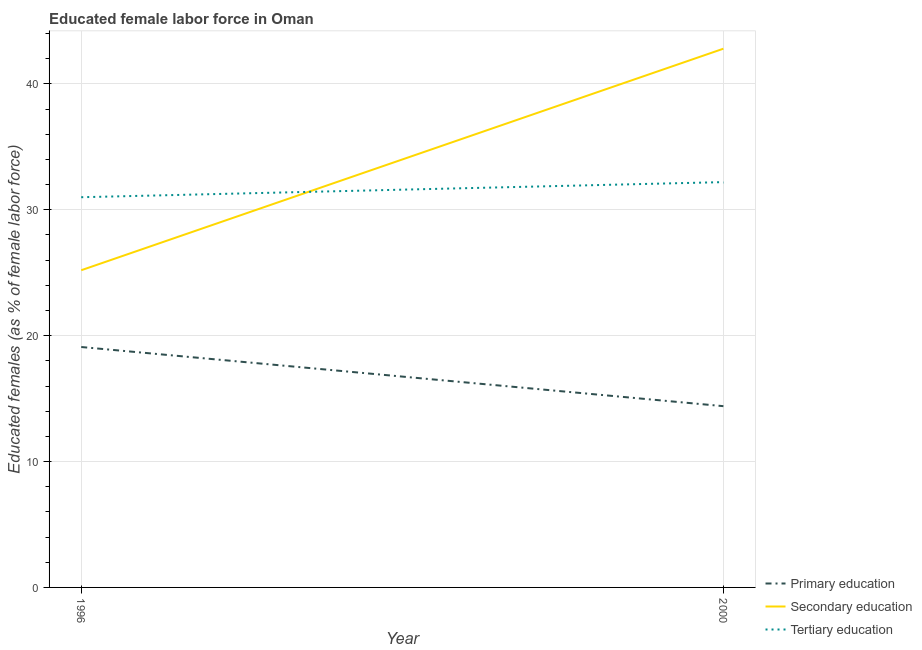What is the percentage of female labor force who received primary education in 1996?
Keep it short and to the point. 19.1. Across all years, what is the maximum percentage of female labor force who received primary education?
Keep it short and to the point. 19.1. Across all years, what is the minimum percentage of female labor force who received secondary education?
Give a very brief answer. 25.2. What is the total percentage of female labor force who received tertiary education in the graph?
Make the answer very short. 63.2. What is the difference between the percentage of female labor force who received primary education in 1996 and that in 2000?
Give a very brief answer. 4.7. What is the difference between the percentage of female labor force who received primary education in 1996 and the percentage of female labor force who received tertiary education in 2000?
Your answer should be compact. -13.1. What is the average percentage of female labor force who received tertiary education per year?
Offer a very short reply. 31.6. In the year 1996, what is the difference between the percentage of female labor force who received secondary education and percentage of female labor force who received tertiary education?
Provide a succinct answer. -5.8. What is the ratio of the percentage of female labor force who received tertiary education in 1996 to that in 2000?
Your answer should be very brief. 0.96. Is the percentage of female labor force who received secondary education in 1996 less than that in 2000?
Your answer should be very brief. Yes. What is the difference between two consecutive major ticks on the Y-axis?
Make the answer very short. 10. Are the values on the major ticks of Y-axis written in scientific E-notation?
Provide a short and direct response. No. Does the graph contain any zero values?
Make the answer very short. No. How many legend labels are there?
Offer a very short reply. 3. How are the legend labels stacked?
Offer a very short reply. Vertical. What is the title of the graph?
Ensure brevity in your answer.  Educated female labor force in Oman. What is the label or title of the X-axis?
Make the answer very short. Year. What is the label or title of the Y-axis?
Provide a short and direct response. Educated females (as % of female labor force). What is the Educated females (as % of female labor force) in Primary education in 1996?
Ensure brevity in your answer.  19.1. What is the Educated females (as % of female labor force) in Secondary education in 1996?
Keep it short and to the point. 25.2. What is the Educated females (as % of female labor force) of Tertiary education in 1996?
Provide a succinct answer. 31. What is the Educated females (as % of female labor force) of Primary education in 2000?
Ensure brevity in your answer.  14.4. What is the Educated females (as % of female labor force) of Secondary education in 2000?
Make the answer very short. 42.8. What is the Educated females (as % of female labor force) of Tertiary education in 2000?
Make the answer very short. 32.2. Across all years, what is the maximum Educated females (as % of female labor force) in Primary education?
Your answer should be very brief. 19.1. Across all years, what is the maximum Educated females (as % of female labor force) of Secondary education?
Your response must be concise. 42.8. Across all years, what is the maximum Educated females (as % of female labor force) in Tertiary education?
Give a very brief answer. 32.2. Across all years, what is the minimum Educated females (as % of female labor force) of Primary education?
Give a very brief answer. 14.4. Across all years, what is the minimum Educated females (as % of female labor force) of Secondary education?
Provide a succinct answer. 25.2. What is the total Educated females (as % of female labor force) in Primary education in the graph?
Make the answer very short. 33.5. What is the total Educated females (as % of female labor force) of Secondary education in the graph?
Your answer should be very brief. 68. What is the total Educated females (as % of female labor force) of Tertiary education in the graph?
Your answer should be compact. 63.2. What is the difference between the Educated females (as % of female labor force) of Secondary education in 1996 and that in 2000?
Keep it short and to the point. -17.6. What is the difference between the Educated females (as % of female labor force) of Primary education in 1996 and the Educated females (as % of female labor force) of Secondary education in 2000?
Your answer should be very brief. -23.7. What is the difference between the Educated females (as % of female labor force) of Primary education in 1996 and the Educated females (as % of female labor force) of Tertiary education in 2000?
Make the answer very short. -13.1. What is the average Educated females (as % of female labor force) of Primary education per year?
Your response must be concise. 16.75. What is the average Educated females (as % of female labor force) in Tertiary education per year?
Your response must be concise. 31.6. In the year 1996, what is the difference between the Educated females (as % of female labor force) of Primary education and Educated females (as % of female labor force) of Secondary education?
Make the answer very short. -6.1. In the year 1996, what is the difference between the Educated females (as % of female labor force) of Primary education and Educated females (as % of female labor force) of Tertiary education?
Keep it short and to the point. -11.9. In the year 2000, what is the difference between the Educated females (as % of female labor force) of Primary education and Educated females (as % of female labor force) of Secondary education?
Ensure brevity in your answer.  -28.4. In the year 2000, what is the difference between the Educated females (as % of female labor force) of Primary education and Educated females (as % of female labor force) of Tertiary education?
Keep it short and to the point. -17.8. In the year 2000, what is the difference between the Educated females (as % of female labor force) in Secondary education and Educated females (as % of female labor force) in Tertiary education?
Keep it short and to the point. 10.6. What is the ratio of the Educated females (as % of female labor force) of Primary education in 1996 to that in 2000?
Provide a succinct answer. 1.33. What is the ratio of the Educated females (as % of female labor force) in Secondary education in 1996 to that in 2000?
Provide a succinct answer. 0.59. What is the ratio of the Educated females (as % of female labor force) in Tertiary education in 1996 to that in 2000?
Offer a very short reply. 0.96. What is the difference between the highest and the second highest Educated females (as % of female labor force) of Primary education?
Offer a terse response. 4.7. What is the difference between the highest and the second highest Educated females (as % of female labor force) in Secondary education?
Provide a short and direct response. 17.6. What is the difference between the highest and the second highest Educated females (as % of female labor force) of Tertiary education?
Give a very brief answer. 1.2. What is the difference between the highest and the lowest Educated females (as % of female labor force) of Primary education?
Keep it short and to the point. 4.7. 